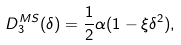Convert formula to latex. <formula><loc_0><loc_0><loc_500><loc_500>D _ { 3 } ^ { M S } ( \delta ) = \frac { 1 } { 2 } \alpha ( 1 - \xi \delta ^ { 2 } ) ,</formula> 